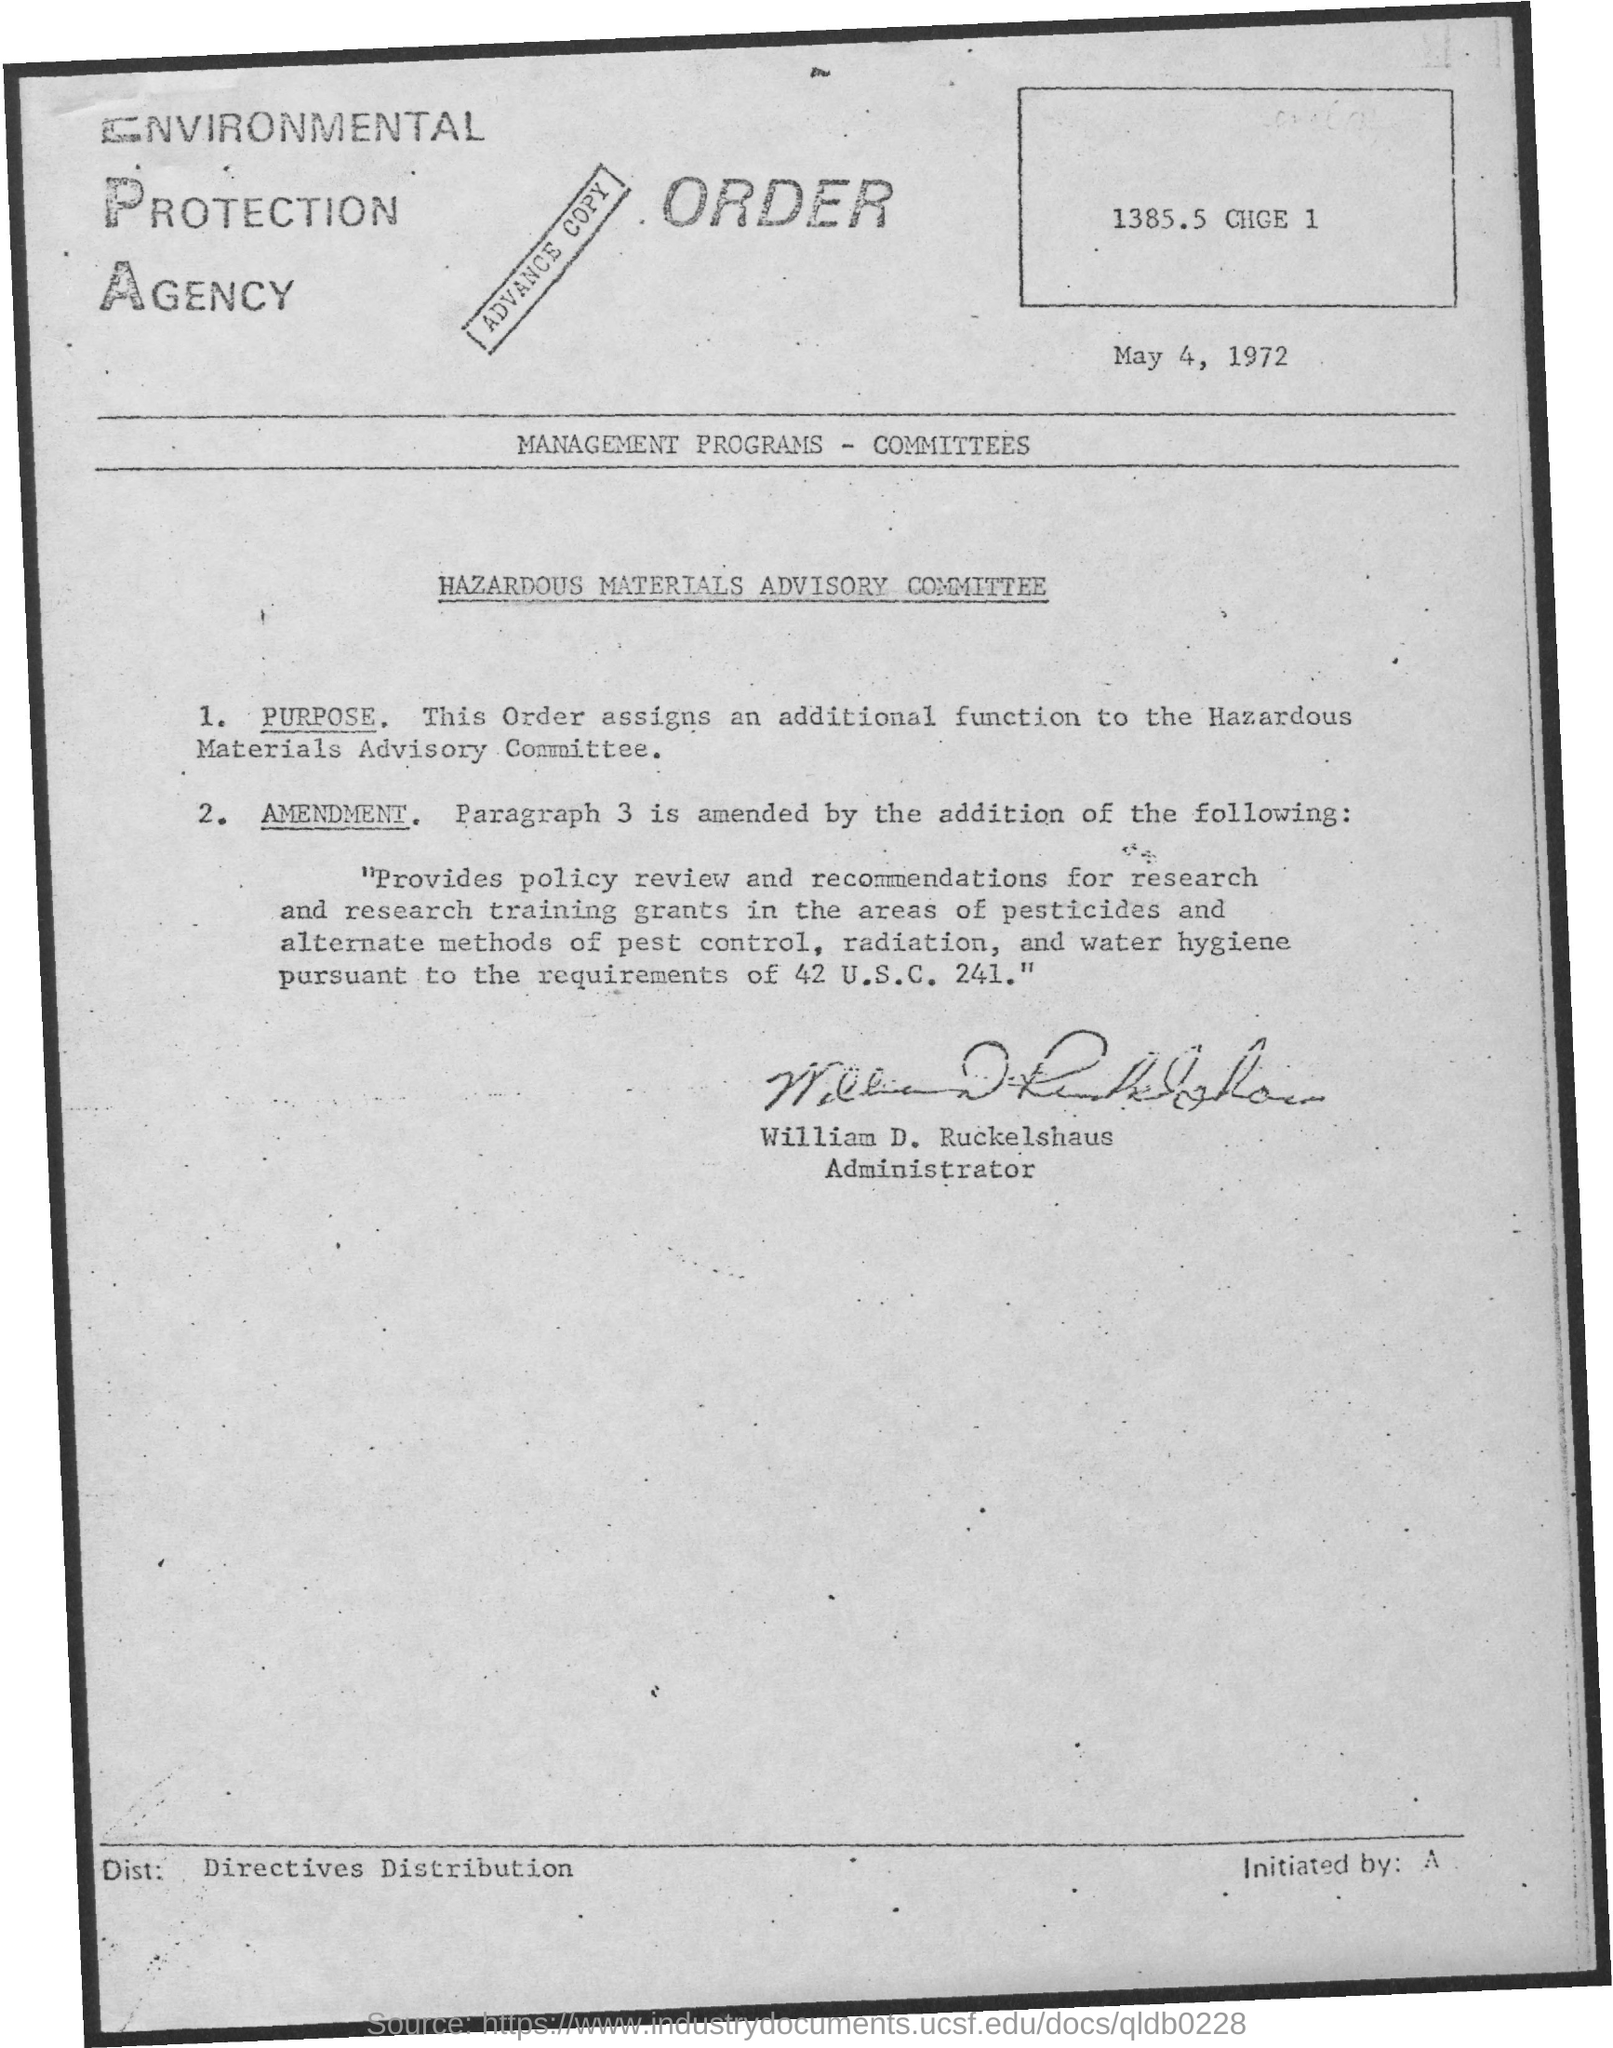What is the date on the document?
Your answer should be compact. May 4, 1972. Who is the Administrator?
Provide a short and direct response. William D. Ruckelshaus. 